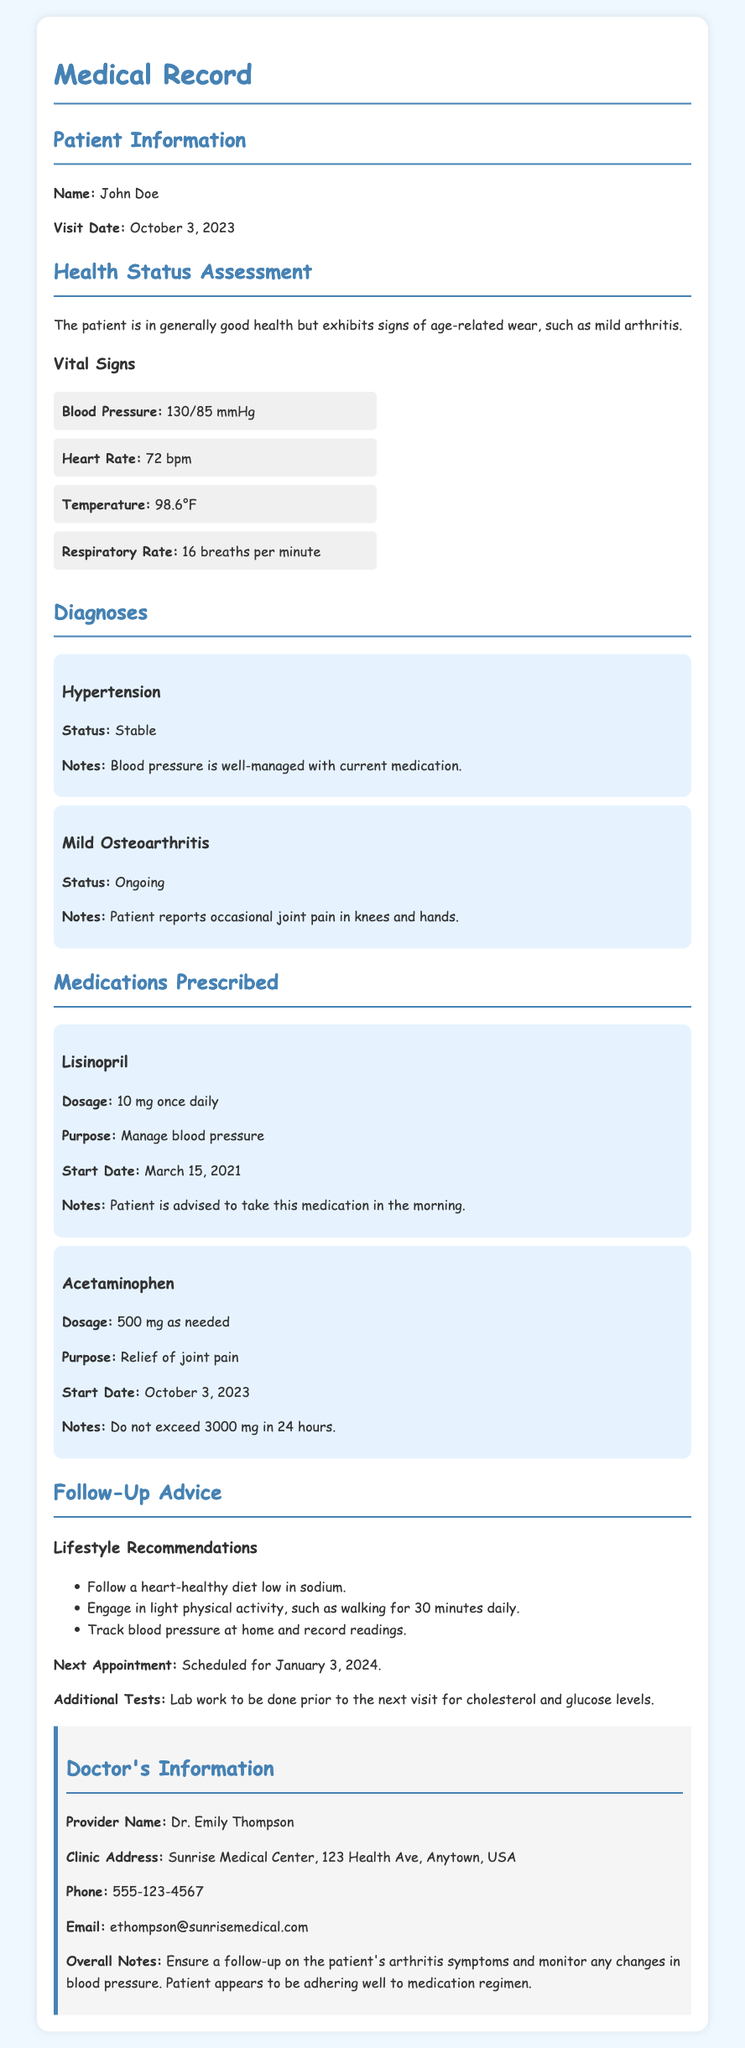What is the patient's name? The patient's name is clearly stated in the document under "Patient Information."
Answer: John Doe What is the date of the visit? The visit date is listed in the "Patient Information" section.
Answer: October 3, 2023 What medication is prescribed for blood pressure? The medication prescribed for blood pressure is found in the "Medications Prescribed" section.
Answer: Lisinopril What is the dosage for Acetaminophen? The dosage for Acetaminophen is specifically stated in the "Medications Prescribed" section.
Answer: 500 mg as needed When is the next appointment scheduled? The next appointment date is mentioned in the "Follow-Up Advice" section.
Answer: January 3, 2024 What vital sign measures the patient's heart activity? The vital sign that measures heart activity is discussed under "Vital Signs."
Answer: Heart Rate How does the patient's blood pressure status appear? The patient’s blood pressure status is summarized in the "Diagnoses" section under hypertension.
Answer: Stable What dietary recommendation is suggested for the patient? The "Follow-Up Advice" section provides lifestyle recommendations, indicating dietary changes.
Answer: Follow a heart-healthy diet low in sodium What is a primary symptom of mild osteoarthritis noted in the record? The patient's symptoms related to osteoarthritis are articulated in the "Diagnoses" section.
Answer: Occasional joint pain 